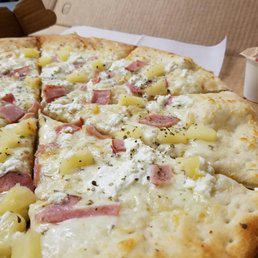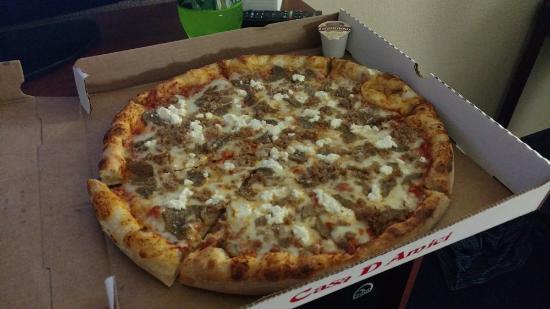The first image is the image on the left, the second image is the image on the right. For the images shown, is this caption "One image shows a complete round pizza, and the other image features at least one pizza slice on a white paper plate." true? Answer yes or no. No. The first image is the image on the left, the second image is the image on the right. Assess this claim about the two images: "There is pizza on a paper plate.". Correct or not? Answer yes or no. No. 